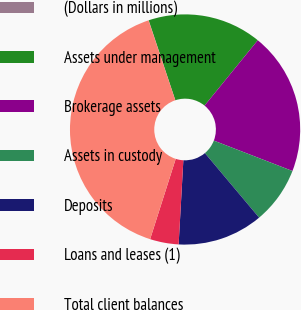Convert chart to OTSL. <chart><loc_0><loc_0><loc_500><loc_500><pie_chart><fcel>(Dollars in millions)<fcel>Assets under management<fcel>Brokerage assets<fcel>Assets in custody<fcel>Deposits<fcel>Loans and leases (1)<fcel>Total client balances<nl><fcel>0.03%<fcel>16.0%<fcel>19.99%<fcel>8.01%<fcel>12.01%<fcel>4.02%<fcel>39.94%<nl></chart> 